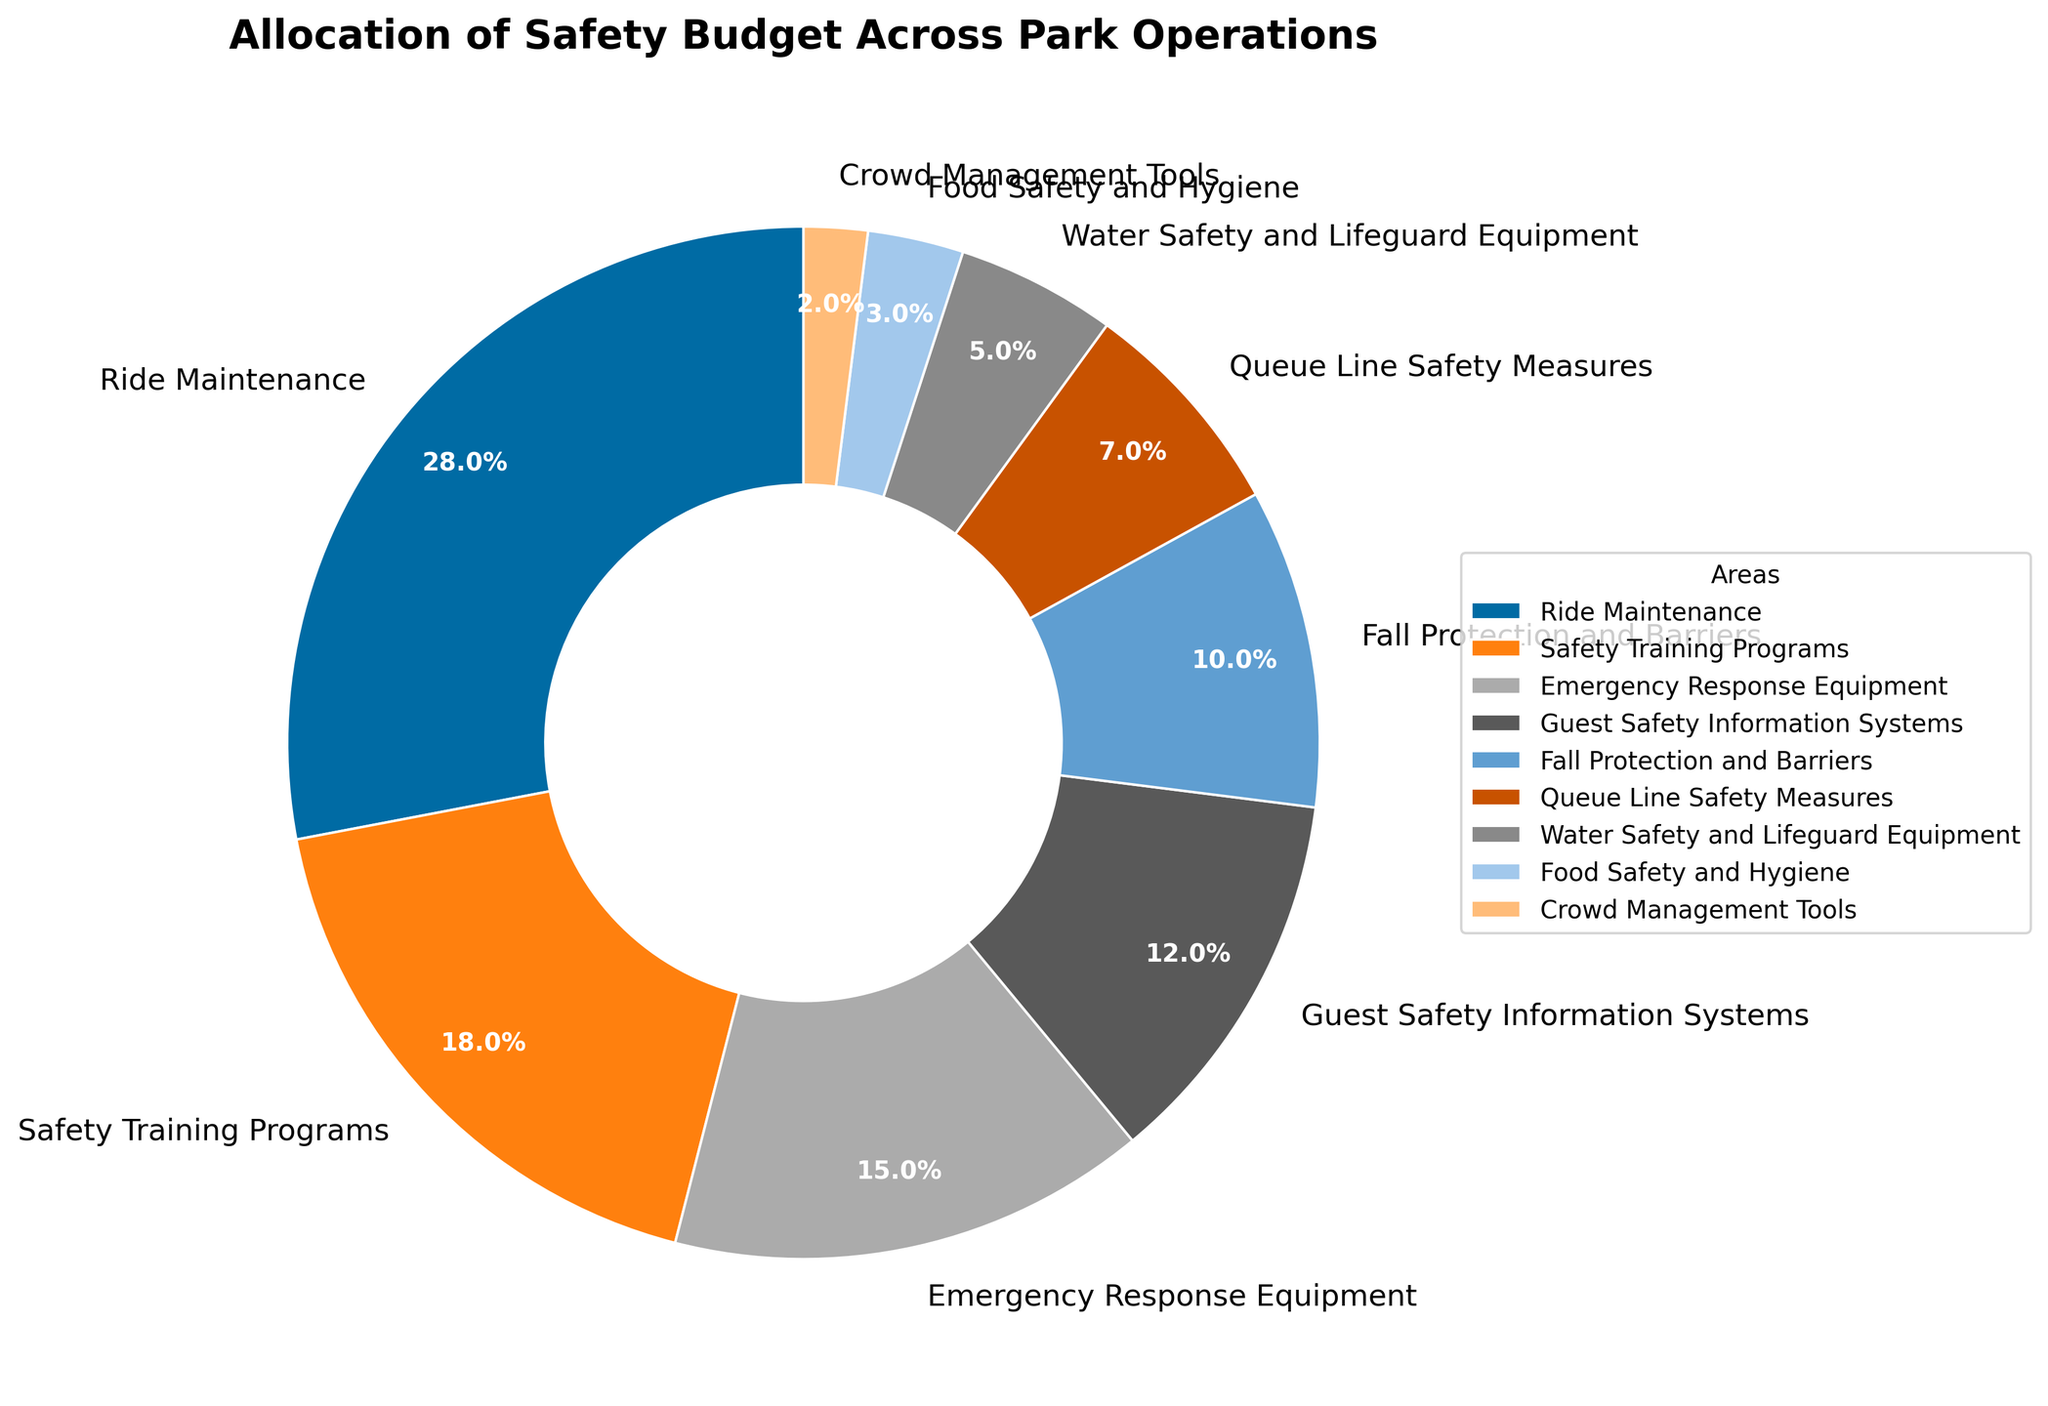Which area receives the highest allocation of the safety budget? Upon examining the pie chart, "Ride Maintenance" is clearly the largest segment.
Answer: Ride Maintenance What is the combined percentage of the budget spent on Guest Safety Information Systems and Food Safety and Hygiene? Adding the percentages for Guest Safety Information Systems (12%) and Food Safety and Hygiene (3%) gives us a combined sum. 12% + 3% = 15%
Answer: 15% What is the difference in percentage allocation between Ride Maintenance and Safety Training Programs? The percentage for Ride Maintenance is 28%, and for Safety Training Programs, it is 18%. Subtracting the smaller percentage from the larger one gives us 28% - 18% = 10%
Answer: 10% How much more of the budget is allocated to Queue Line Safety Measures than to Crowd Management Tools? The percentage for Queue Line Safety Measures is 7%, and for Crowd Management Tools, it is 2%. The difference is 7% - 2% = 5%
Answer: 5% Is the allocation for Emergency Response Equipment greater or smaller than the allocation for Fall Protection and Barriers? The percentage for Emergency Response Equipment is 15%, and for Fall Protection and Barriers, it is 10%. Since 15% is greater than 10%, the former allocation is greater.
Answer: Greater Which three areas have the smallest budget allocations, and what is their total combined percentage? The three smallest segments are Crowd Management Tools (2%), Food Safety and Hygiene (3%), and Water Safety and Lifeguard Equipment (5%). Adding these percentages gives us 2% + 3% + 5% = 10%
Answer: Crowd Management Tools, Food Safety and Hygiene, Water Safety and Lifeguard Equipment; 10% What is the average percentage allocation for Water Safety and Lifeguard Equipment, Fall Protection and Barriers, and Queue Line Safety Measures? The percentages are 5% for Water Safety and Lifeguard Equipment, 10% for Fall Protection and Barriers, and 7% for Queue Line Safety Measures. Adding these and dividing by three gives (5% + 10% + 7%) / 3 = 22% / 3 ≈ 7.33%
Answer: 7.33% Between Guest Safety Information Systems and Fall Protection and Barriers, which area has a higher allocation and by how much? Guest Safety Information Systems has 12% and Fall Protection and Barriers has 10%. The difference is 12% - 10% = 2%
Answer: Guest Safety Information Systems, 2% Which areas collectively receive more than half of the total budget? By adding the percentages, 28% (Ride Maintenance) + 18% (Safety Training Programs) + 15% (Emergency Response Equipment) = 61%, which is more than half the budget. Collectively, these three areas receive more than half the budget.
Answer: Ride Maintenance, Safety Training Programs, Emergency Response Equipment 